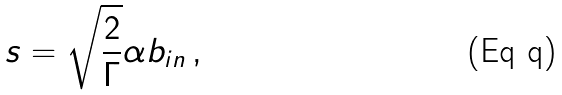Convert formula to latex. <formula><loc_0><loc_0><loc_500><loc_500>s = \sqrt { \frac { 2 } { \Gamma } } \alpha b _ { i n } \, ,</formula> 